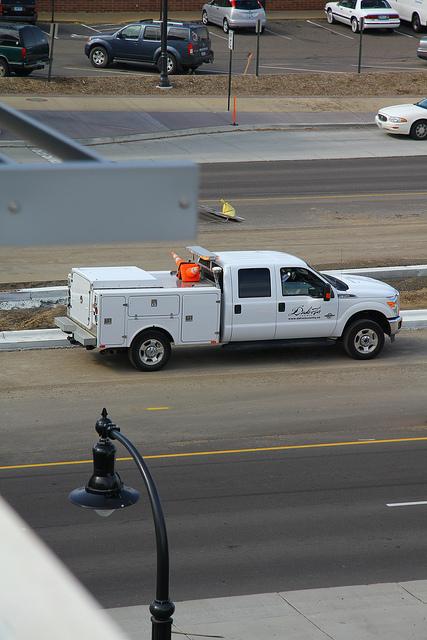Does this look safe?
Be succinct. Yes. Is the white vehicle moving?
Give a very brief answer. Yes. Why is there writing on the door of the truck?
Answer briefly. Advertisement. Does the truck have a crew cab?
Short answer required. Yes. 